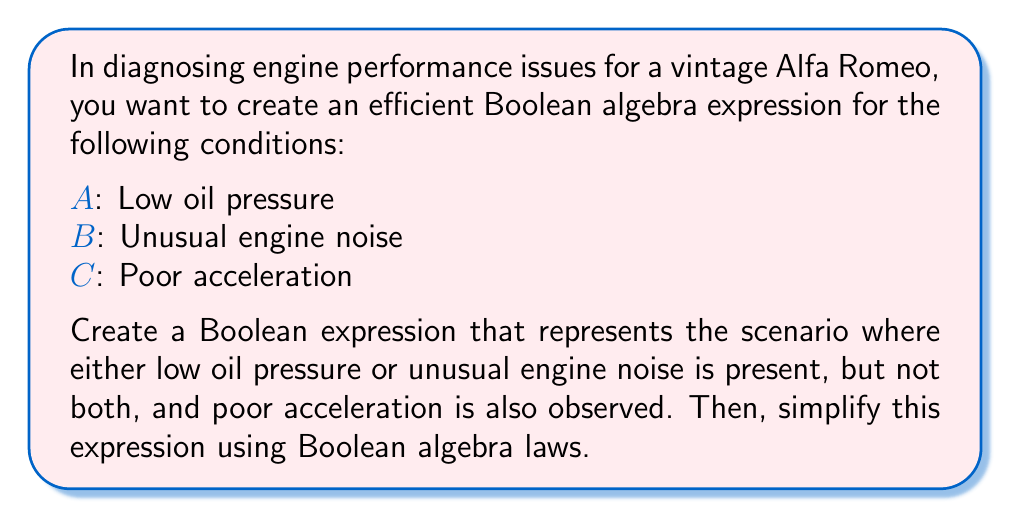Help me with this question. Let's approach this step-by-step:

1) First, we need to translate the given scenario into a Boolean expression:
   - "Either low oil pressure or unusual engine noise is present, but not both" can be represented by the XOR operation (⊕).
   - "Poor acceleration is also observed" means we need to AND this condition with the above.

   So, our initial expression is: $$(A \oplus B) \cdot C$$

2) Let's expand this using the definition of XOR:
   $$(A \oplus B) \cdot C = ((A \cdot \overline{B}) + (\overline{A} \cdot B)) \cdot C$$

3) Now, we can apply the distributive law:
   $$((A \cdot \overline{B}) + (\overline{A} \cdot B)) \cdot C = (A \cdot \overline{B} \cdot C) + (\overline{A} \cdot B \cdot C)$$

4) This expression is already in its simplest form, known as the sum of products (SOP) form. It can be interpreted as:
   - Either (Low oil pressure AND NOT unusual engine noise AND poor acceleration)
   - OR (NOT low oil pressure AND unusual engine noise AND poor acceleration)

5) This Boolean expression can be used to create an efficient diagnostic flowchart for these specific engine performance problems in a vintage Alfa Romeo.
Answer: $(A \cdot \overline{B} \cdot C) + (\overline{A} \cdot B \cdot C)$ 